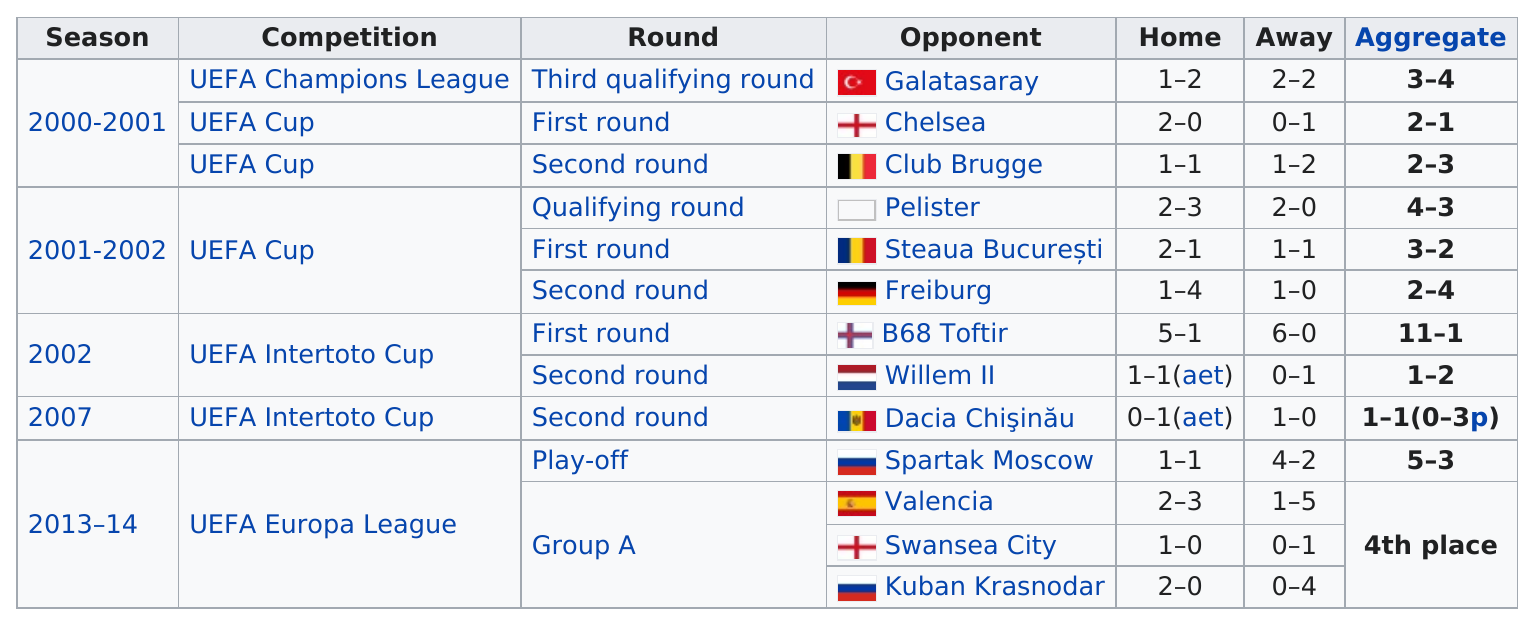Point out several critical features in this image. The team made it to the first round three times. St. Gallen won five out of the home games played during the season. The season after 2002 is 2007. The UEFA Europa League is the last competition listed on the table. There are 14 years represented in this table. 